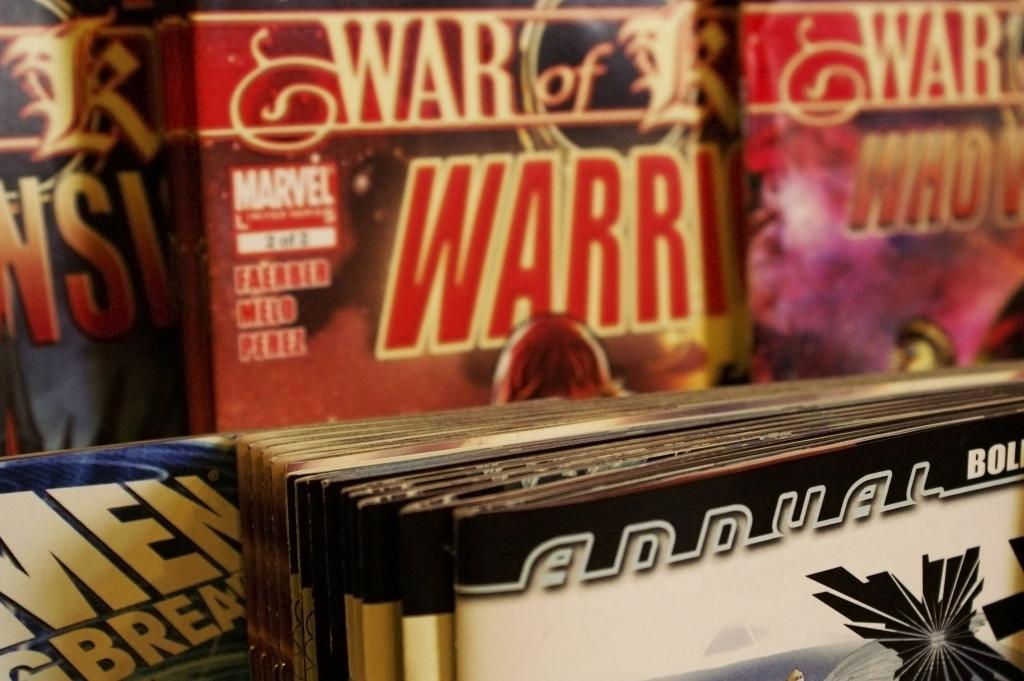<image>
Provide a brief description of the given image. The comics in the background are from Marvel comics. 